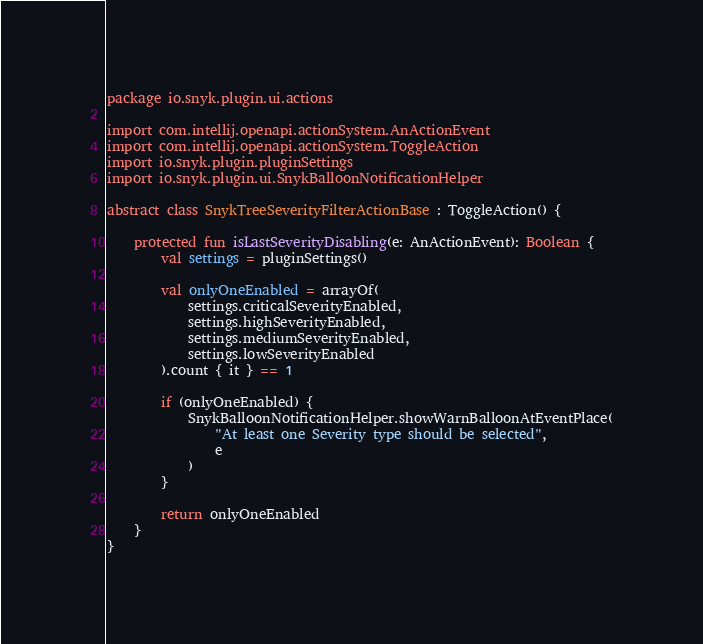<code> <loc_0><loc_0><loc_500><loc_500><_Kotlin_>package io.snyk.plugin.ui.actions

import com.intellij.openapi.actionSystem.AnActionEvent
import com.intellij.openapi.actionSystem.ToggleAction
import io.snyk.plugin.pluginSettings
import io.snyk.plugin.ui.SnykBalloonNotificationHelper

abstract class SnykTreeSeverityFilterActionBase : ToggleAction() {

    protected fun isLastSeverityDisabling(e: AnActionEvent): Boolean {
        val settings = pluginSettings()

        val onlyOneEnabled = arrayOf(
            settings.criticalSeverityEnabled,
            settings.highSeverityEnabled,
            settings.mediumSeverityEnabled,
            settings.lowSeverityEnabled
        ).count { it } == 1

        if (onlyOneEnabled) {
            SnykBalloonNotificationHelper.showWarnBalloonAtEventPlace(
                "At least one Severity type should be selected",
                e
            )
        }

        return onlyOneEnabled
    }
}
</code> 